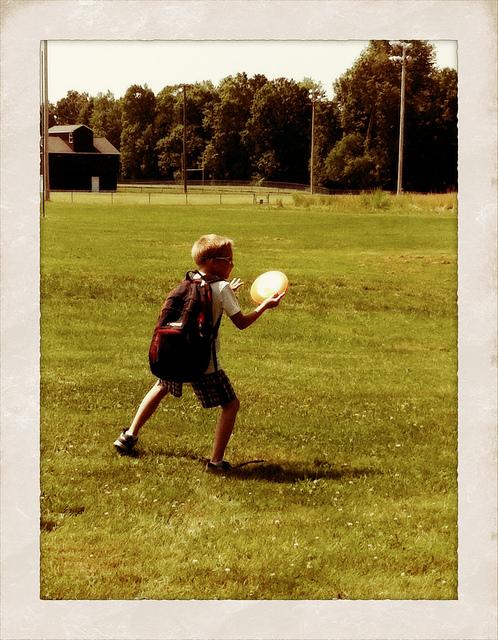What is the person holding?
Write a very short answer. Frisbee. Is he playing with a frisbee?
Quick response, please. Yes. What is the child carrying?
Quick response, please. Frisbee. Is his backpack large for his size?
Concise answer only. Yes. How many different games are going on in the picture?
Answer briefly. 1. 